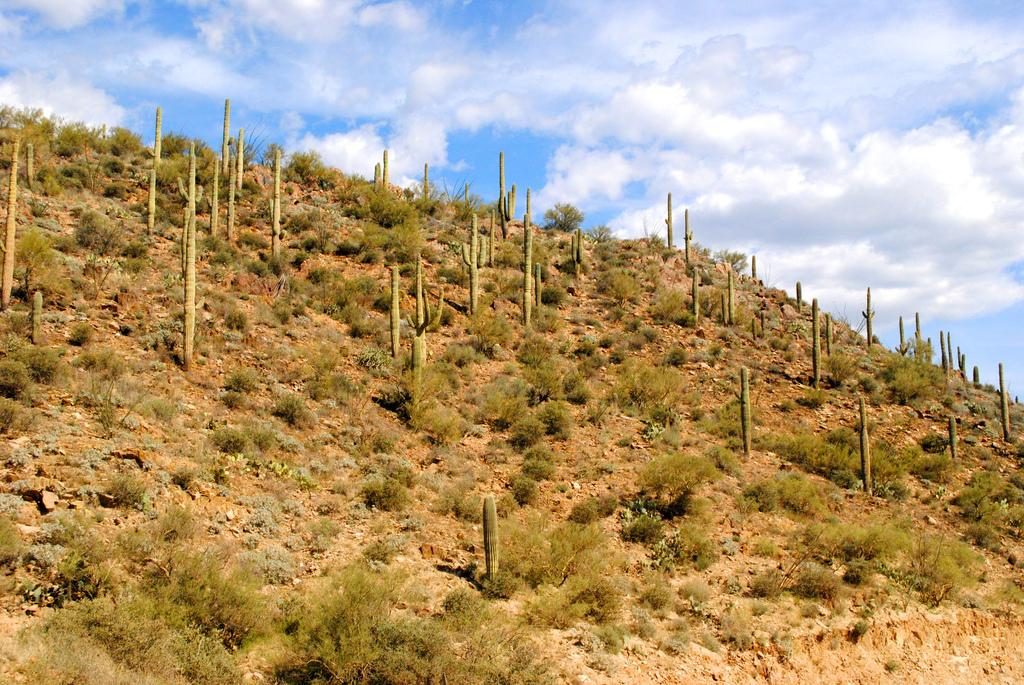What type of terrain is visible in the image? There is a hill surface with plants in the image. What is visible in the background of the image? The sky is visible in the image. What can be seen in the sky? Clouds are present in the sky. What type of floor can be seen in the image? There is no floor present in the image; it features a hill surface with plants. Is there an office visible in the image? There is no office present in the image; it features a hill surface with plants and a sky with clouds. 